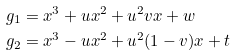Convert formula to latex. <formula><loc_0><loc_0><loc_500><loc_500>g _ { 1 } & = x ^ { 3 } + u x ^ { 2 } + u ^ { 2 } v x + w \\ g _ { 2 } & = x ^ { 3 } - u x ^ { 2 } + u ^ { 2 } ( 1 - v ) x + t</formula> 